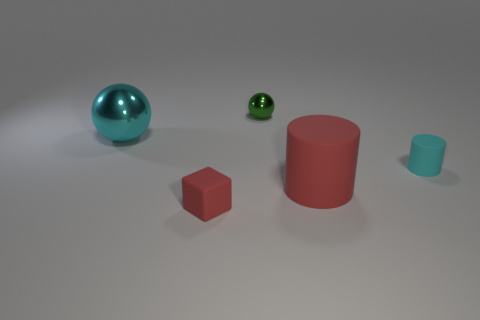What size is the cyan thing on the right side of the tiny green shiny ball?
Your answer should be very brief. Small. How many red objects are the same size as the cyan matte thing?
Offer a very short reply. 1. The small thing that is both left of the small cyan thing and in front of the green object is made of what material?
Give a very brief answer. Rubber. There is a object that is the same size as the red cylinder; what is it made of?
Your answer should be very brief. Metal. There is a cyan thing that is on the right side of the large object behind the small rubber object on the right side of the large red object; what is its size?
Your answer should be compact. Small. There is a object that is made of the same material as the big sphere; what size is it?
Your answer should be compact. Small. There is a cyan cylinder; does it have the same size as the cyan object that is on the left side of the red cylinder?
Your answer should be compact. No. What shape is the large object on the left side of the red rubber cylinder?
Offer a terse response. Sphere. There is a red object that is behind the red thing to the left of the tiny metal thing; is there a small cyan object that is to the left of it?
Your answer should be very brief. No. There is another thing that is the same shape as the large red object; what material is it?
Offer a terse response. Rubber. 